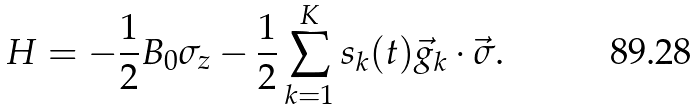Convert formula to latex. <formula><loc_0><loc_0><loc_500><loc_500>H = - \frac { 1 } { 2 } B _ { 0 } \sigma _ { z } - \frac { 1 } { 2 } \sum _ { k = 1 } ^ { K } s _ { k } ( t ) \vec { g } _ { k } \cdot \vec { \sigma } .</formula> 